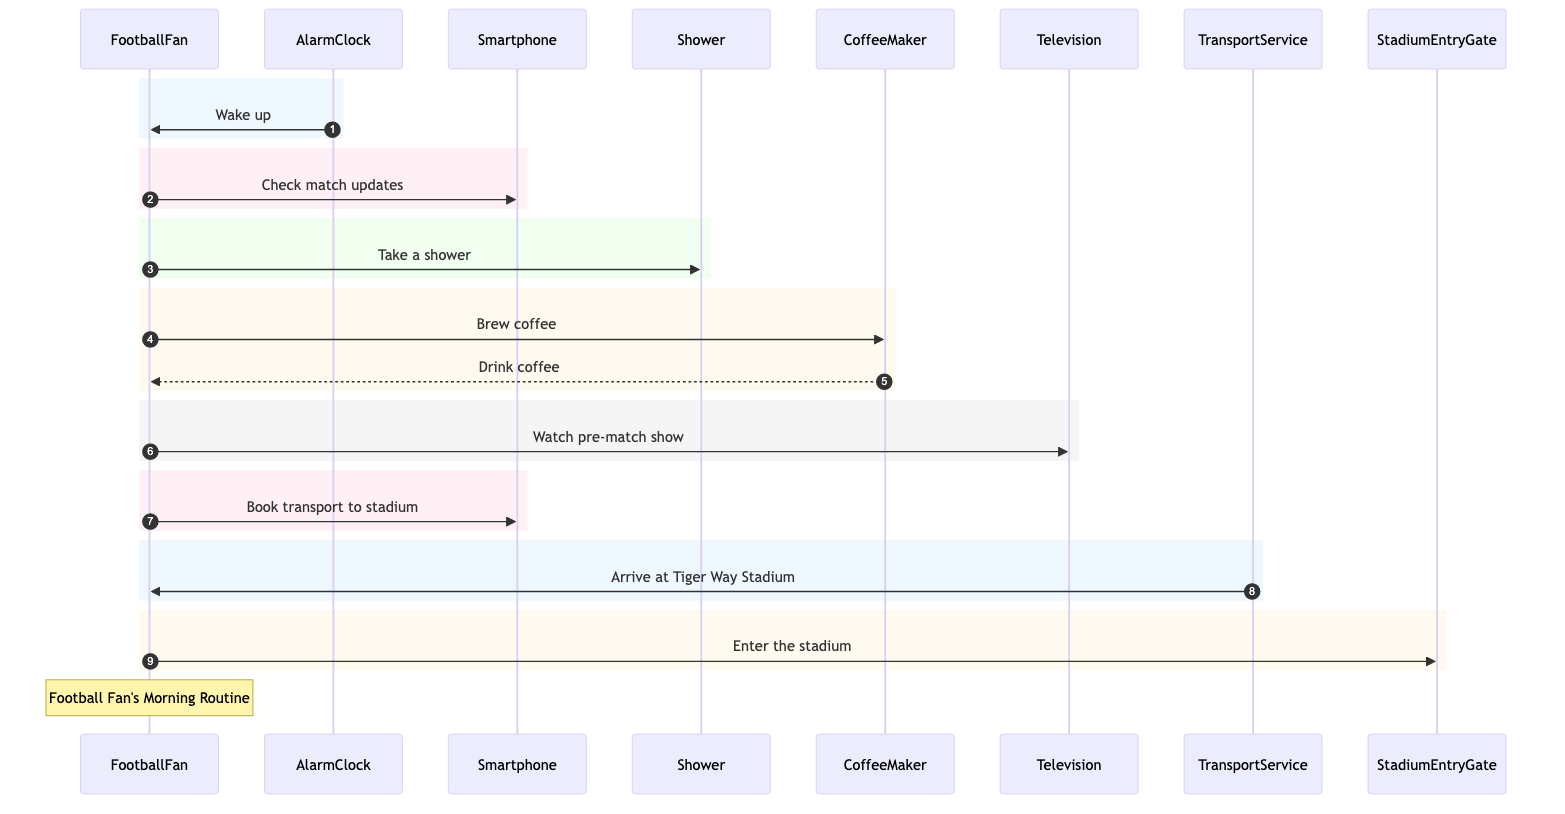What's the first action taken by the Football Fan? The sequence diagram begins with the AlarmClock sending a message to the FootballFan labeled "Wake up", indicating that this is the first action in the morning routine.
Answer: Wake up How many main participants are in the sequence diagram? Counting the listed actors, there are a total of eight participants: FootballFan, AlarmClock, Smartphone, Shower, CoffeeMaker, Television, TransportService, and StadiumEntryGate.
Answer: Eight Which device does the Football Fan use to check match updates? According to the diagram, the FootballFan sends a message to the Smartphone with the action "Check match updates", indicating that the Smartphone is the device used for this purpose.
Answer: Smartphone What is the final action performed by the Football Fan before arriving at the stadium? The sequence shows that the FootballFan sends a message to the StadiumEntryGate labeled "Enter the stadium", which is the last action before arriving at the stadium and indicates completion of the routine.
Answer: Enter the stadium How does the CoffeeMaker interact with the Football Fan? The CoffeeMaker first receives a message from the FootballFan labeled "Brew coffee" and then sends a response "Drink coffee" back to the FootballFan, showing the interaction between these two participants.
Answer: Drink coffee In what sequence does the Football Fan take a shower and brew coffee? The diagram illustrates that the FootballFan sends a message labeled "Take a shower" to the Shower before sending a message labeled "Brew coffee" to the CoffeeMaker, indicating that showering occurs before brewing the coffee.
Answer: Shower then Brew coffee How many messages are exchanged between the Football Fan and the Smartphone? There are two messages exchanged between the FootballFan and Smartphone: one for "Check match updates" and the other for "Book transport to stadium", hence a total of two messages are exchanged.
Answer: Two At what point does the Football Fan watch the pre-match show? The sequence shows that the FootballFan interacts with the Television to "Watch pre-match show" after drinking coffee, placing this action after the coffee preparation step in the morning routine.
Answer: After coffee 